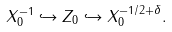Convert formula to latex. <formula><loc_0><loc_0><loc_500><loc_500>X _ { 0 } ^ { - 1 } \hookrightarrow Z _ { 0 } \hookrightarrow X _ { 0 } ^ { - 1 / 2 + \delta } .</formula> 